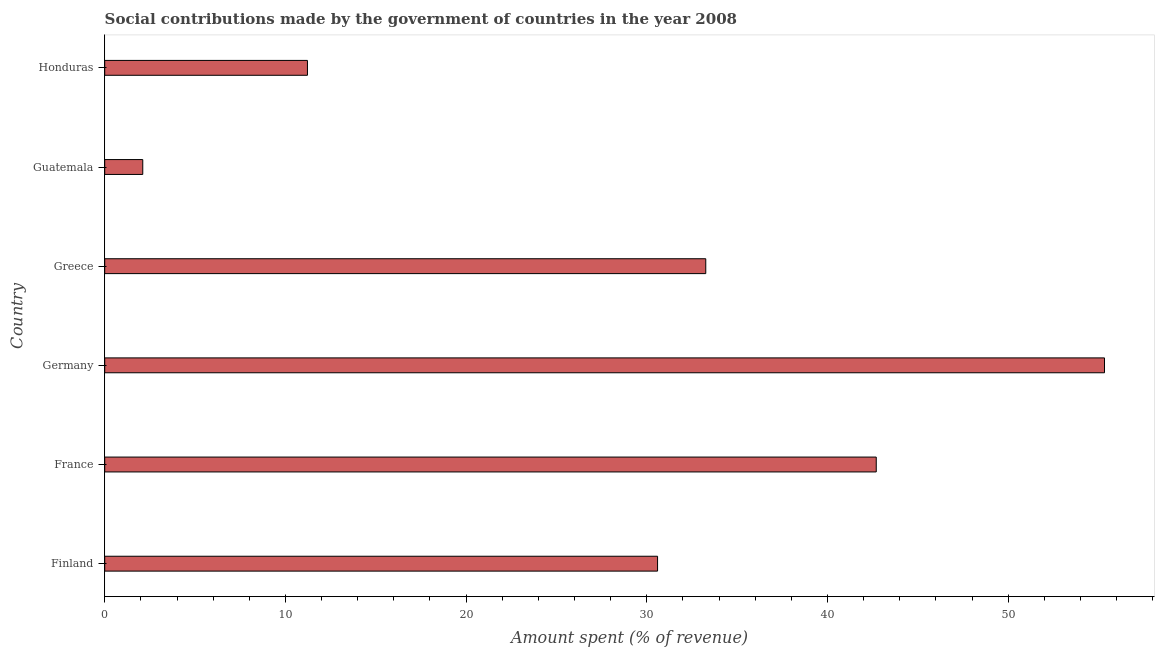What is the title of the graph?
Give a very brief answer. Social contributions made by the government of countries in the year 2008. What is the label or title of the X-axis?
Ensure brevity in your answer.  Amount spent (% of revenue). What is the label or title of the Y-axis?
Ensure brevity in your answer.  Country. What is the amount spent in making social contributions in Finland?
Offer a terse response. 30.59. Across all countries, what is the maximum amount spent in making social contributions?
Keep it short and to the point. 55.33. Across all countries, what is the minimum amount spent in making social contributions?
Provide a succinct answer. 2.11. In which country was the amount spent in making social contributions maximum?
Your answer should be very brief. Germany. In which country was the amount spent in making social contributions minimum?
Offer a terse response. Guatemala. What is the sum of the amount spent in making social contributions?
Make the answer very short. 175.2. What is the difference between the amount spent in making social contributions in France and Germany?
Your response must be concise. -12.63. What is the average amount spent in making social contributions per country?
Your answer should be compact. 29.2. What is the median amount spent in making social contributions?
Provide a short and direct response. 31.93. In how many countries, is the amount spent in making social contributions greater than 34 %?
Give a very brief answer. 2. Is the amount spent in making social contributions in Germany less than that in Guatemala?
Give a very brief answer. No. Is the difference between the amount spent in making social contributions in France and Germany greater than the difference between any two countries?
Ensure brevity in your answer.  No. What is the difference between the highest and the second highest amount spent in making social contributions?
Give a very brief answer. 12.63. Is the sum of the amount spent in making social contributions in Greece and Guatemala greater than the maximum amount spent in making social contributions across all countries?
Provide a succinct answer. No. What is the difference between the highest and the lowest amount spent in making social contributions?
Give a very brief answer. 53.22. How many countries are there in the graph?
Give a very brief answer. 6. Are the values on the major ticks of X-axis written in scientific E-notation?
Your answer should be very brief. No. What is the Amount spent (% of revenue) of Finland?
Make the answer very short. 30.59. What is the Amount spent (% of revenue) in France?
Your answer should be very brief. 42.7. What is the Amount spent (% of revenue) of Germany?
Offer a terse response. 55.33. What is the Amount spent (% of revenue) of Greece?
Provide a succinct answer. 33.26. What is the Amount spent (% of revenue) of Guatemala?
Keep it short and to the point. 2.11. What is the Amount spent (% of revenue) of Honduras?
Offer a very short reply. 11.22. What is the difference between the Amount spent (% of revenue) in Finland and France?
Keep it short and to the point. -12.1. What is the difference between the Amount spent (% of revenue) in Finland and Germany?
Give a very brief answer. -24.73. What is the difference between the Amount spent (% of revenue) in Finland and Greece?
Make the answer very short. -2.67. What is the difference between the Amount spent (% of revenue) in Finland and Guatemala?
Your answer should be compact. 28.49. What is the difference between the Amount spent (% of revenue) in Finland and Honduras?
Offer a very short reply. 19.37. What is the difference between the Amount spent (% of revenue) in France and Germany?
Your response must be concise. -12.63. What is the difference between the Amount spent (% of revenue) in France and Greece?
Keep it short and to the point. 9.43. What is the difference between the Amount spent (% of revenue) in France and Guatemala?
Provide a short and direct response. 40.59. What is the difference between the Amount spent (% of revenue) in France and Honduras?
Offer a terse response. 31.48. What is the difference between the Amount spent (% of revenue) in Germany and Greece?
Your answer should be very brief. 22.07. What is the difference between the Amount spent (% of revenue) in Germany and Guatemala?
Your response must be concise. 53.22. What is the difference between the Amount spent (% of revenue) in Germany and Honduras?
Offer a very short reply. 44.11. What is the difference between the Amount spent (% of revenue) in Greece and Guatemala?
Provide a short and direct response. 31.15. What is the difference between the Amount spent (% of revenue) in Greece and Honduras?
Give a very brief answer. 22.04. What is the difference between the Amount spent (% of revenue) in Guatemala and Honduras?
Keep it short and to the point. -9.11. What is the ratio of the Amount spent (% of revenue) in Finland to that in France?
Offer a terse response. 0.72. What is the ratio of the Amount spent (% of revenue) in Finland to that in Germany?
Provide a succinct answer. 0.55. What is the ratio of the Amount spent (% of revenue) in Finland to that in Greece?
Provide a short and direct response. 0.92. What is the ratio of the Amount spent (% of revenue) in Finland to that in Guatemala?
Provide a short and direct response. 14.53. What is the ratio of the Amount spent (% of revenue) in Finland to that in Honduras?
Your answer should be very brief. 2.73. What is the ratio of the Amount spent (% of revenue) in France to that in Germany?
Keep it short and to the point. 0.77. What is the ratio of the Amount spent (% of revenue) in France to that in Greece?
Your answer should be very brief. 1.28. What is the ratio of the Amount spent (% of revenue) in France to that in Guatemala?
Make the answer very short. 20.27. What is the ratio of the Amount spent (% of revenue) in France to that in Honduras?
Your answer should be very brief. 3.81. What is the ratio of the Amount spent (% of revenue) in Germany to that in Greece?
Your response must be concise. 1.66. What is the ratio of the Amount spent (% of revenue) in Germany to that in Guatemala?
Make the answer very short. 26.27. What is the ratio of the Amount spent (% of revenue) in Germany to that in Honduras?
Keep it short and to the point. 4.93. What is the ratio of the Amount spent (% of revenue) in Greece to that in Guatemala?
Your answer should be compact. 15.79. What is the ratio of the Amount spent (% of revenue) in Greece to that in Honduras?
Make the answer very short. 2.96. What is the ratio of the Amount spent (% of revenue) in Guatemala to that in Honduras?
Your answer should be compact. 0.19. 